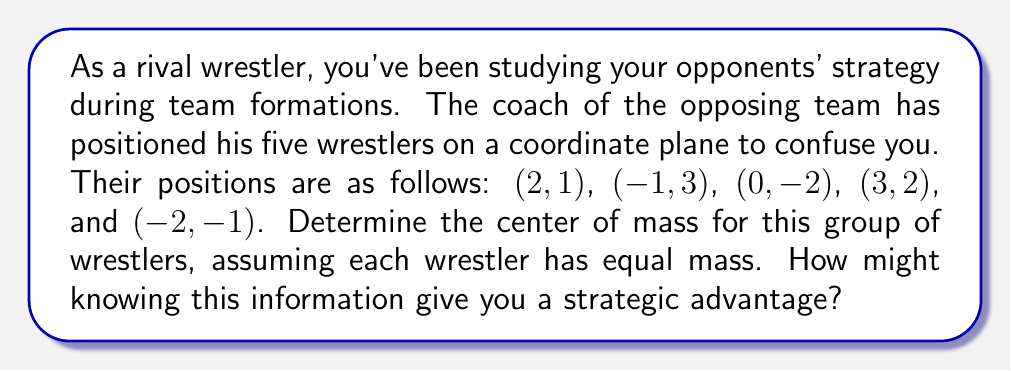What is the answer to this math problem? To determine the center of mass for a group of objects with equal mass, we need to calculate the average of their x-coordinates and y-coordinates separately.

Let's break this down step-by-step:

1) First, let's list out all the x-coordinates and y-coordinates:
   x-coordinates: 2, -1, 0, 3, -2
   y-coordinates: 1, 3, -2, 2, -1

2) To find the x-coordinate of the center of mass, we calculate the average of the x-coordinates:
   $$x_{center} = \frac{2 + (-1) + 0 + 3 + (-2)}{5} = \frac{2}{5} = 0.4$$

3) Similarly, for the y-coordinate of the center of mass, we calculate the average of the y-coordinates:
   $$y_{center} = \frac{1 + 3 + (-2) + 2 + (-1)}{5} = \frac{3}{5} = 0.6$$

4) Therefore, the center of mass is at the point (0.4, 0.6).

Understanding the center of mass can give you a strategic advantage because:
- It represents the average position of the team, which could indicate their overall strategy or focus.
- Knowing this point might help you anticipate their collective movements or identify potential weak spots in their formation.
- You could use this information to position yourself or your team members optimally to counter their strategy.
Answer: The center of mass for the group of wrestlers is at the point (0.4, 0.6). 